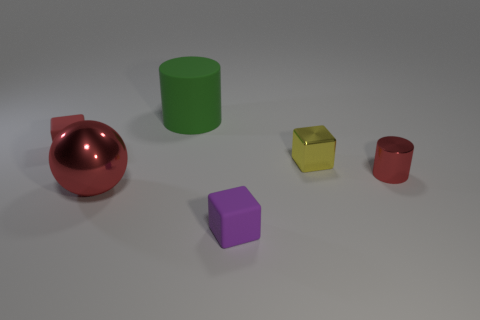Subtract all tiny red blocks. How many blocks are left? 2 Add 2 tiny purple rubber objects. How many objects exist? 8 Subtract all purple cubes. How many cubes are left? 2 Subtract all spheres. How many objects are left? 5 Subtract 1 cylinders. How many cylinders are left? 1 Subtract 1 purple cubes. How many objects are left? 5 Subtract all red blocks. Subtract all purple cylinders. How many blocks are left? 2 Subtract all matte spheres. Subtract all yellow metallic cubes. How many objects are left? 5 Add 2 small yellow cubes. How many small yellow cubes are left? 3 Add 1 green matte cylinders. How many green matte cylinders exist? 2 